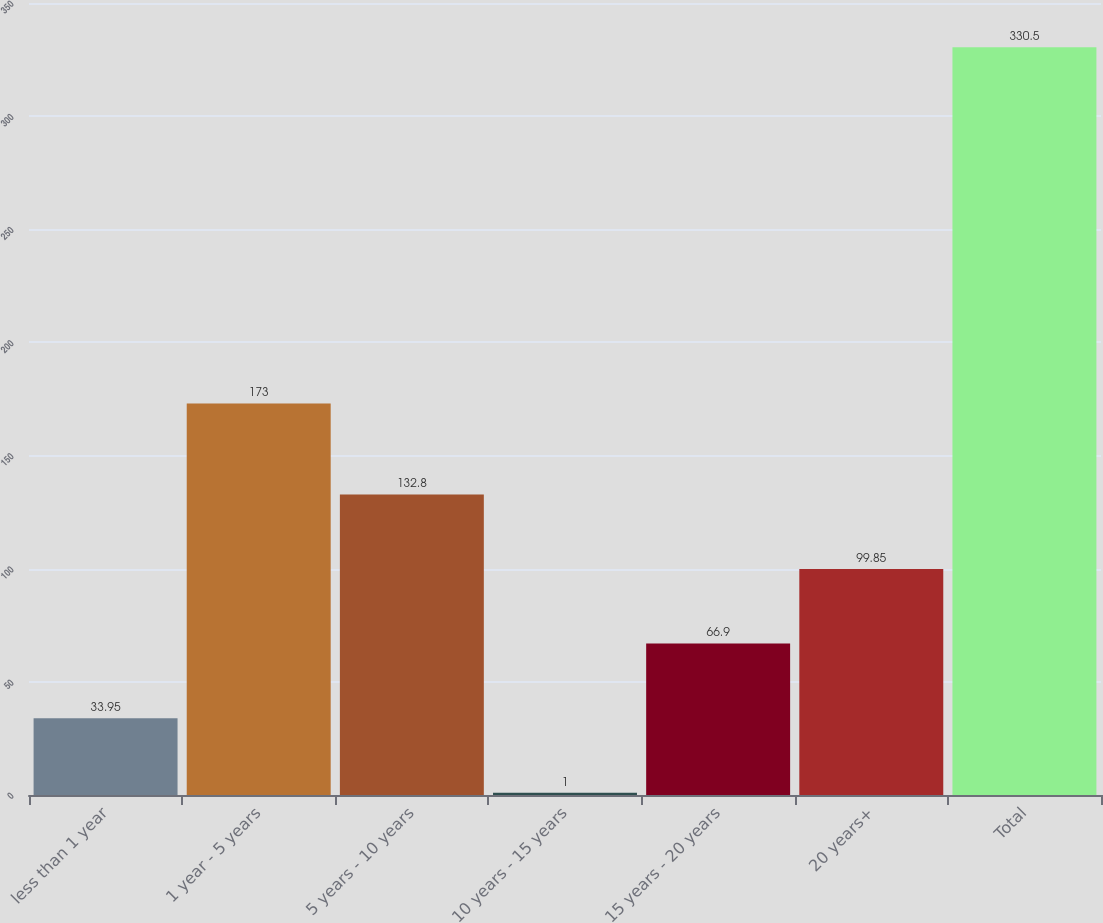Convert chart to OTSL. <chart><loc_0><loc_0><loc_500><loc_500><bar_chart><fcel>less than 1 year<fcel>1 year - 5 years<fcel>5 years - 10 years<fcel>10 years - 15 years<fcel>15 years - 20 years<fcel>20 years+<fcel>Total<nl><fcel>33.95<fcel>173<fcel>132.8<fcel>1<fcel>66.9<fcel>99.85<fcel>330.5<nl></chart> 